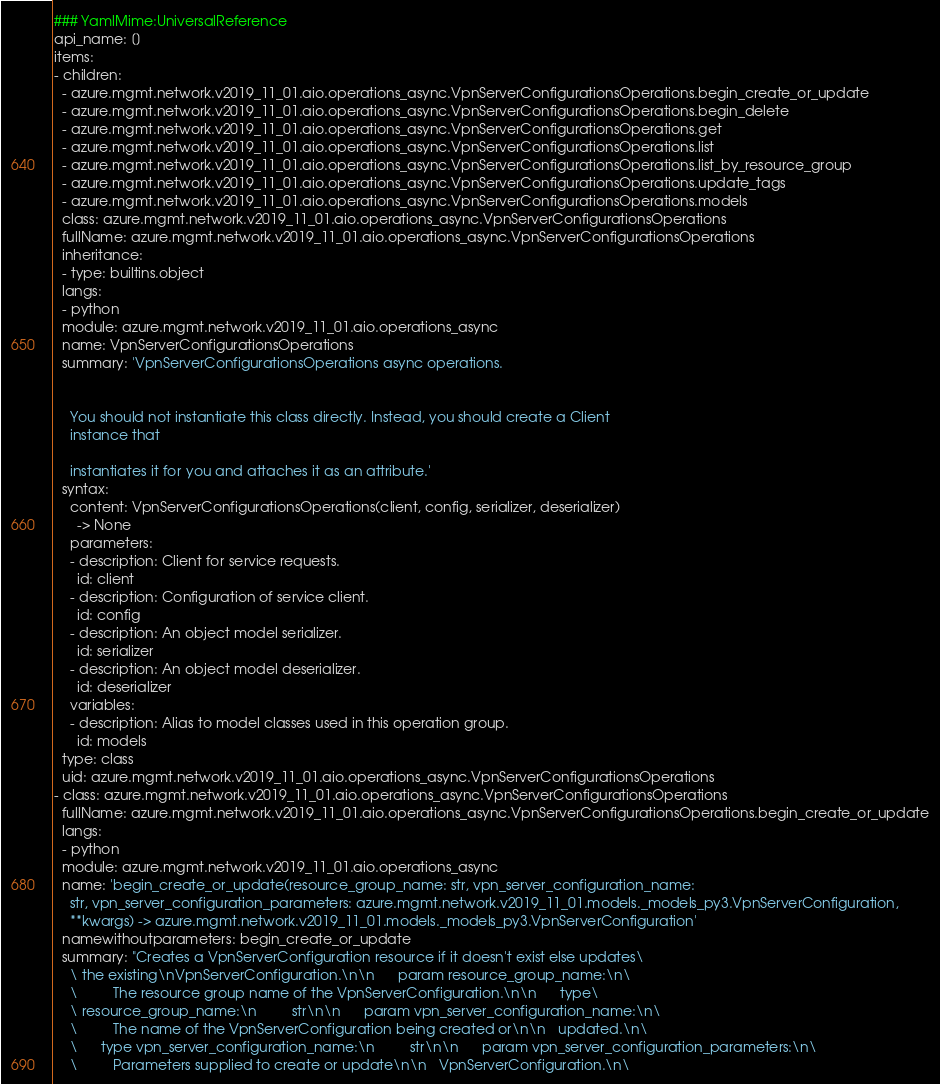<code> <loc_0><loc_0><loc_500><loc_500><_YAML_>### YamlMime:UniversalReference
api_name: []
items:
- children:
  - azure.mgmt.network.v2019_11_01.aio.operations_async.VpnServerConfigurationsOperations.begin_create_or_update
  - azure.mgmt.network.v2019_11_01.aio.operations_async.VpnServerConfigurationsOperations.begin_delete
  - azure.mgmt.network.v2019_11_01.aio.operations_async.VpnServerConfigurationsOperations.get
  - azure.mgmt.network.v2019_11_01.aio.operations_async.VpnServerConfigurationsOperations.list
  - azure.mgmt.network.v2019_11_01.aio.operations_async.VpnServerConfigurationsOperations.list_by_resource_group
  - azure.mgmt.network.v2019_11_01.aio.operations_async.VpnServerConfigurationsOperations.update_tags
  - azure.mgmt.network.v2019_11_01.aio.operations_async.VpnServerConfigurationsOperations.models
  class: azure.mgmt.network.v2019_11_01.aio.operations_async.VpnServerConfigurationsOperations
  fullName: azure.mgmt.network.v2019_11_01.aio.operations_async.VpnServerConfigurationsOperations
  inheritance:
  - type: builtins.object
  langs:
  - python
  module: azure.mgmt.network.v2019_11_01.aio.operations_async
  name: VpnServerConfigurationsOperations
  summary: 'VpnServerConfigurationsOperations async operations.


    You should not instantiate this class directly. Instead, you should create a Client
    instance that

    instantiates it for you and attaches it as an attribute.'
  syntax:
    content: VpnServerConfigurationsOperations(client, config, serializer, deserializer)
      -> None
    parameters:
    - description: Client for service requests.
      id: client
    - description: Configuration of service client.
      id: config
    - description: An object model serializer.
      id: serializer
    - description: An object model deserializer.
      id: deserializer
    variables:
    - description: Alias to model classes used in this operation group.
      id: models
  type: class
  uid: azure.mgmt.network.v2019_11_01.aio.operations_async.VpnServerConfigurationsOperations
- class: azure.mgmt.network.v2019_11_01.aio.operations_async.VpnServerConfigurationsOperations
  fullName: azure.mgmt.network.v2019_11_01.aio.operations_async.VpnServerConfigurationsOperations.begin_create_or_update
  langs:
  - python
  module: azure.mgmt.network.v2019_11_01.aio.operations_async
  name: 'begin_create_or_update(resource_group_name: str, vpn_server_configuration_name:
    str, vpn_server_configuration_parameters: azure.mgmt.network.v2019_11_01.models._models_py3.VpnServerConfiguration,
    **kwargs) -> azure.mgmt.network.v2019_11_01.models._models_py3.VpnServerConfiguration'
  namewithoutparameters: begin_create_or_update
  summary: "Creates a VpnServerConfiguration resource if it doesn't exist else updates\
    \ the existing\nVpnServerConfiguration.\n\n      param resource_group_name:\n\
    \         The resource group name of the VpnServerConfiguration.\n\n      type\
    \ resource_group_name:\n         str\n\n      param vpn_server_configuration_name:\n\
    \         The name of the VpnServerConfiguration being created or\n\n   updated.\n\
    \      type vpn_server_configuration_name:\n         str\n\n      param vpn_server_configuration_parameters:\n\
    \         Parameters supplied to create or update\n\n   VpnServerConfiguration.\n\</code> 